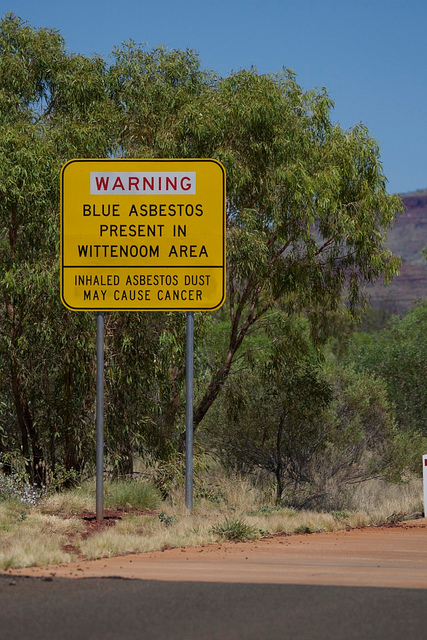<image>What is the name of the street? I don't know the name of the street. It could be 'wittenoom', 'main', or 'warning blue asbestos'. What is the name of the street? I don't know the name of the street. It can be 'none', 'wittenoom', 'warning', 'unknown', 'unclear', or 'main'. 